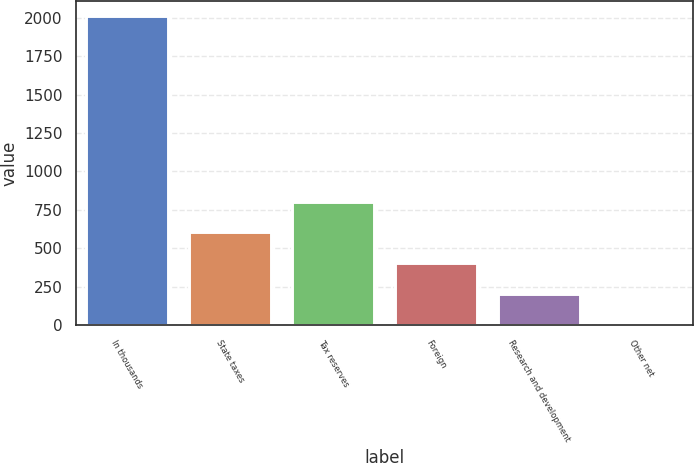<chart> <loc_0><loc_0><loc_500><loc_500><bar_chart><fcel>In thousands<fcel>State taxes<fcel>Tax reserves<fcel>Foreign<fcel>Research and development<fcel>Other net<nl><fcel>2009<fcel>602.84<fcel>803.72<fcel>401.96<fcel>201.08<fcel>0.2<nl></chart> 